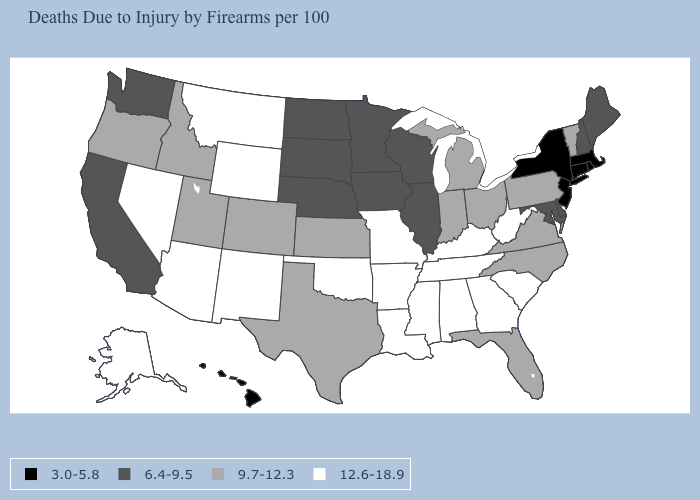What is the value of Kansas?
Write a very short answer. 9.7-12.3. Among the states that border Ohio , which have the highest value?
Be succinct. Kentucky, West Virginia. What is the value of Connecticut?
Quick response, please. 3.0-5.8. Name the states that have a value in the range 9.7-12.3?
Concise answer only. Colorado, Florida, Idaho, Indiana, Kansas, Michigan, North Carolina, Ohio, Oregon, Pennsylvania, Texas, Utah, Vermont, Virginia. What is the value of Connecticut?
Short answer required. 3.0-5.8. Name the states that have a value in the range 6.4-9.5?
Keep it brief. California, Delaware, Illinois, Iowa, Maine, Maryland, Minnesota, Nebraska, New Hampshire, North Dakota, South Dakota, Washington, Wisconsin. Name the states that have a value in the range 9.7-12.3?
Write a very short answer. Colorado, Florida, Idaho, Indiana, Kansas, Michigan, North Carolina, Ohio, Oregon, Pennsylvania, Texas, Utah, Vermont, Virginia. Does Colorado have the same value as West Virginia?
Short answer required. No. Does Pennsylvania have a lower value than Tennessee?
Concise answer only. Yes. Does the map have missing data?
Quick response, please. No. Does Michigan have the lowest value in the USA?
Give a very brief answer. No. How many symbols are there in the legend?
Quick response, please. 4. Which states hav the highest value in the Northeast?
Write a very short answer. Pennsylvania, Vermont. What is the highest value in the USA?
Short answer required. 12.6-18.9. Does Iowa have a higher value than New Jersey?
Be succinct. Yes. 